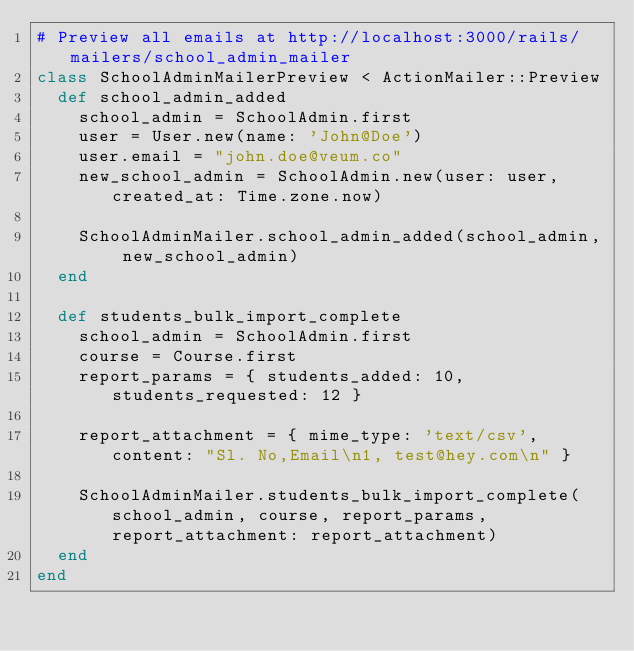<code> <loc_0><loc_0><loc_500><loc_500><_Ruby_># Preview all emails at http://localhost:3000/rails/mailers/school_admin_mailer
class SchoolAdminMailerPreview < ActionMailer::Preview
  def school_admin_added
    school_admin = SchoolAdmin.first
    user = User.new(name: 'John@Doe')
    user.email = "john.doe@veum.co"
    new_school_admin = SchoolAdmin.new(user: user, created_at: Time.zone.now)

    SchoolAdminMailer.school_admin_added(school_admin, new_school_admin)
  end

  def students_bulk_import_complete
    school_admin = SchoolAdmin.first
    course = Course.first
    report_params = { students_added: 10, students_requested: 12 }

    report_attachment = { mime_type: 'text/csv', content: "Sl. No,Email\n1, test@hey.com\n" }

    SchoolAdminMailer.students_bulk_import_complete(school_admin, course, report_params, report_attachment: report_attachment)
  end
end
</code> 